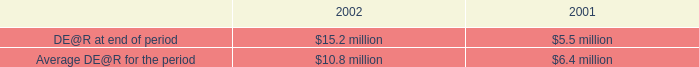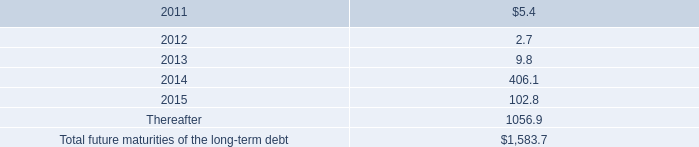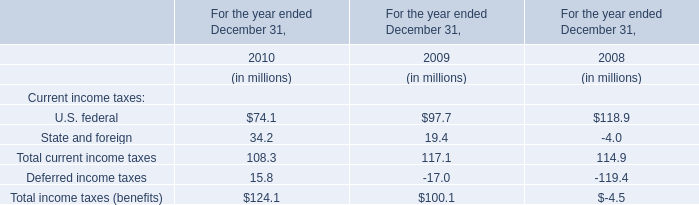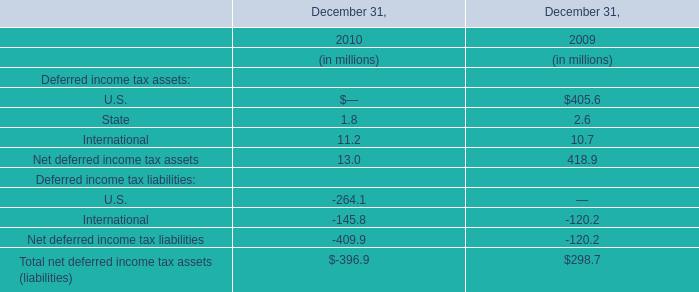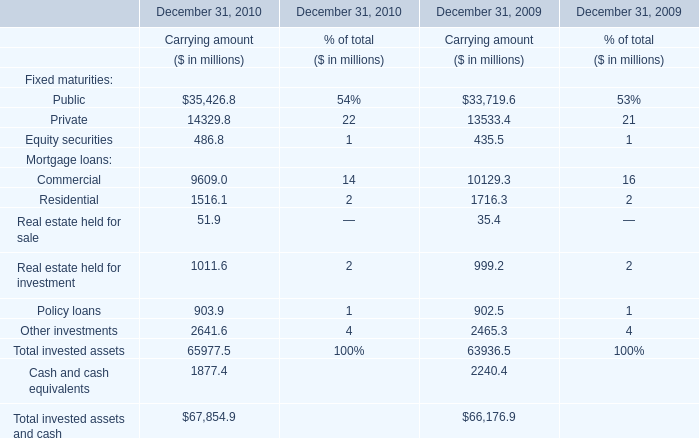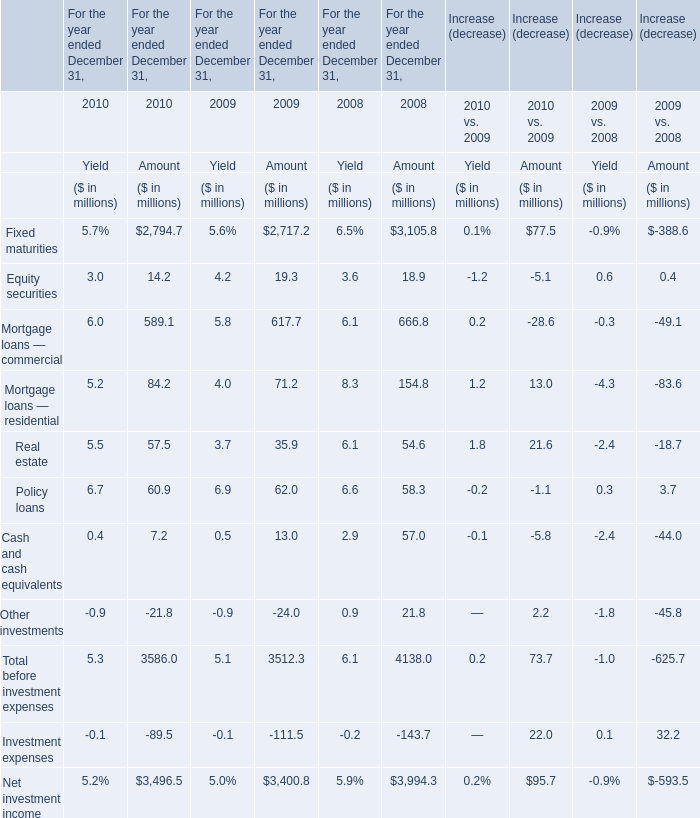For the year ended December 31 where the amount of Cash and cash equivalents is greater than 50 million,what is the amount of Equity securities? (in million) 
Answer: 18.9. 